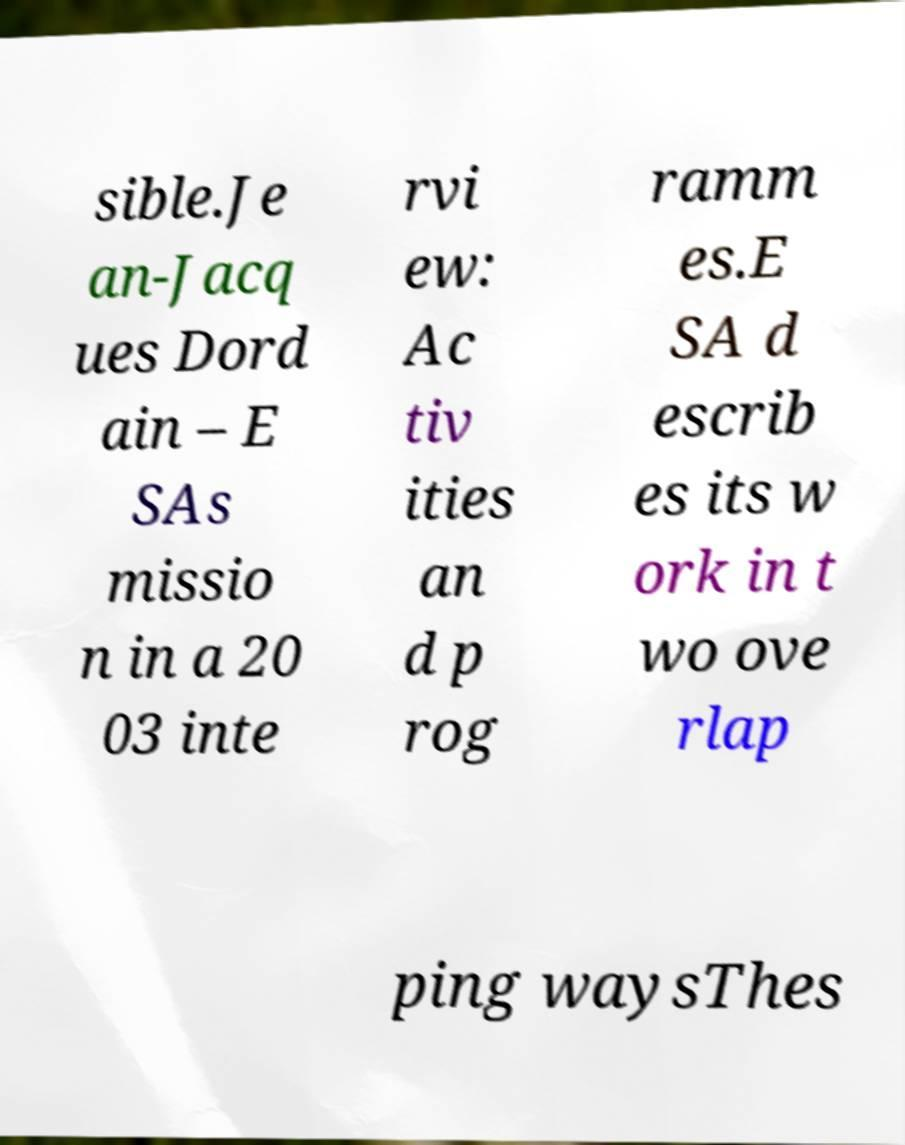Could you extract and type out the text from this image? sible.Je an-Jacq ues Dord ain – E SAs missio n in a 20 03 inte rvi ew: Ac tiv ities an d p rog ramm es.E SA d escrib es its w ork in t wo ove rlap ping waysThes 